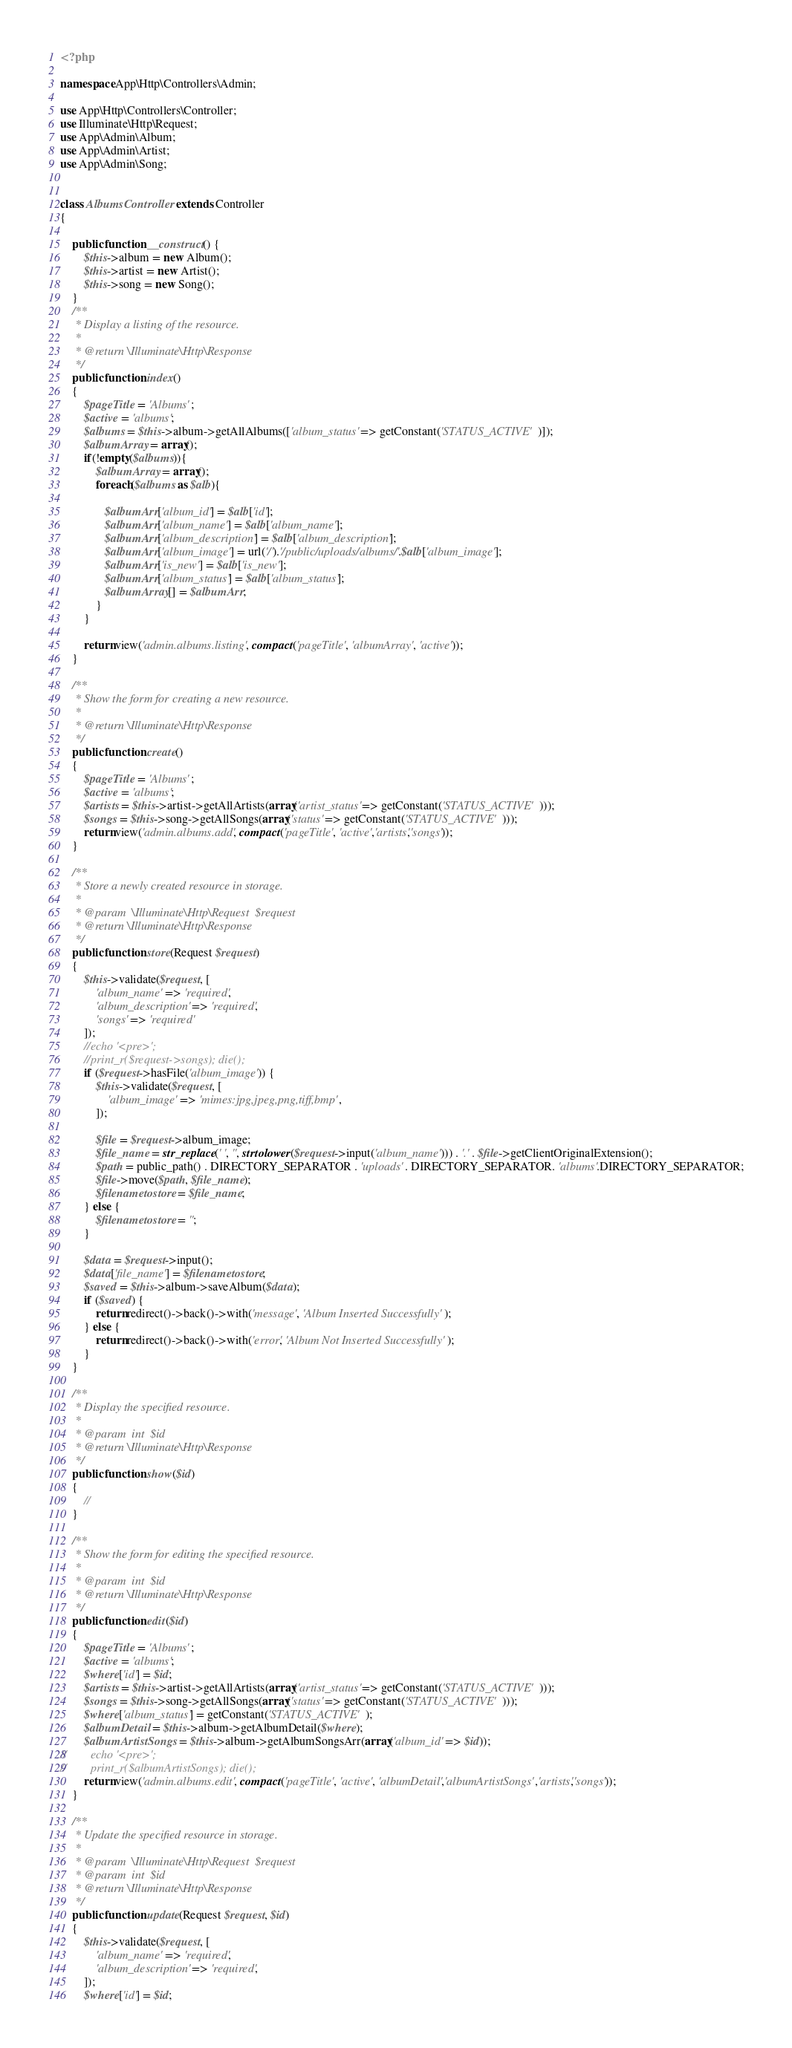Convert code to text. <code><loc_0><loc_0><loc_500><loc_500><_PHP_><?php

namespace App\Http\Controllers\Admin;

use App\Http\Controllers\Controller;
use Illuminate\Http\Request;
use App\Admin\Album;
use App\Admin\Artist;
use App\Admin\Song;


class AlbumsController extends Controller
{
    
    public function __construct() {
        $this->album = new Album();
        $this->artist = new Artist();
        $this->song = new Song();
    }
    /**
     * Display a listing of the resource.
     *
     * @return \Illuminate\Http\Response
     */
    public function index()
    {
        $pageTitle = 'Albums';
        $active = 'albums';
        $albums = $this->album->getAllAlbums(['album_status' => getConstant('STATUS_ACTIVE')]);
        $albumArray = array();
        if(!empty($albums)){
            $albumArray = array();
            foreach($albums as $alb){
                
               $albumArr['album_id'] = $alb['id']; 
               $albumArr['album_name'] = $alb['album_name']; 
               $albumArr['album_description'] = $alb['album_description']; 
               $albumArr['album_image'] = url('/').'/public/uploads/albums/'.$alb['album_image'];
               $albumArr['is_new'] = $alb['is_new'];
               $albumArr['album_status'] = $alb['album_status'];
               $albumArray[] = $albumArr;
            }
        }

        return view('admin.albums.listing', compact('pageTitle', 'albumArray', 'active'));
    }

    /**
     * Show the form for creating a new resource.
     *
     * @return \Illuminate\Http\Response
     */
    public function create()
    {
        $pageTitle = 'Albums';
        $active = 'albums';
        $artists = $this->artist->getAllArtists(array('artist_status' => getConstant('STATUS_ACTIVE')));
        $songs = $this->song->getAllSongs(array('status' => getConstant('STATUS_ACTIVE')));
        return view('admin.albums.add', compact('pageTitle', 'active','artists','songs'));
    }

    /**
     * Store a newly created resource in storage.
     *
     * @param  \Illuminate\Http\Request  $request
     * @return \Illuminate\Http\Response
     */
    public function store(Request $request)
    {
        $this->validate($request, [
            'album_name' => 'required',
            'album_description' => 'required',
            'songs' => 'required'
        ]);
        //echo '<pre>';
        //print_r($request->songs); die();
        if ($request->hasFile('album_image')) {
            $this->validate($request, [
                'album_image' => 'mimes:jpg,jpeg,png,tiff,bmp',
            ]);
            
            $file = $request->album_image;
            $file_name = str_replace(' ', '', strtolower($request->input('album_name'))) . '.' . $file->getClientOriginalExtension();
            $path = public_path() . DIRECTORY_SEPARATOR . 'uploads' . DIRECTORY_SEPARATOR. 'albums'.DIRECTORY_SEPARATOR;
            $file->move($path, $file_name);
            $filenametostore = $file_name;
        } else {
            $filenametostore = '';
        }
        
        $data = $request->input();
        $data['file_name'] = $filenametostore;
        $saved = $this->album->saveAlbum($data);
        if ($saved) {
            return redirect()->back()->with('message', 'Album Inserted Successfully');
        } else {
            return redirect()->back()->with('error', 'Album Not Inserted Successfully');
        }
    }

    /**
     * Display the specified resource.
     *
     * @param  int  $id
     * @return \Illuminate\Http\Response
     */
    public function show($id)
    {
        //
    }

    /**
     * Show the form for editing the specified resource.
     *
     * @param  int  $id
     * @return \Illuminate\Http\Response
     */
    public function edit($id)
    {
        $pageTitle = 'Albums';
        $active = 'albums';
        $where['id'] = $id;
        $artists = $this->artist->getAllArtists(array('artist_status' => getConstant('STATUS_ACTIVE')));
        $songs = $this->song->getAllSongs(array('status' => getConstant('STATUS_ACTIVE')));
        $where['album_status'] = getConstant('STATUS_ACTIVE');
        $albumDetail = $this->album->getAlbumDetail($where);
        $albumArtistSongs = $this->album->getAlbumSongsArr(array('album_id' => $id));
//        echo '<pre>';
//        print_r($albumArtistSongs); die();
        return view('admin.albums.edit', compact('pageTitle', 'active', 'albumDetail','albumArtistSongs','artists','songs'));
    }

    /**
     * Update the specified resource in storage.
     *
     * @param  \Illuminate\Http\Request  $request
     * @param  int  $id
     * @return \Illuminate\Http\Response
     */
    public function update(Request $request, $id)
    {
        $this->validate($request, [
            'album_name' => 'required',
            'album_description' => 'required',
        ]);
        $where['id'] = $id;</code> 